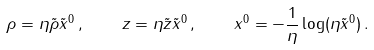<formula> <loc_0><loc_0><loc_500><loc_500>\rho = \eta \tilde { \rho } \tilde { x } ^ { 0 } \, , \quad z = \eta \tilde { z } \tilde { x } ^ { 0 } \, , \quad x ^ { 0 } = - \frac { 1 } { \eta } \log ( \eta \tilde { x } ^ { 0 } ) \, .</formula> 